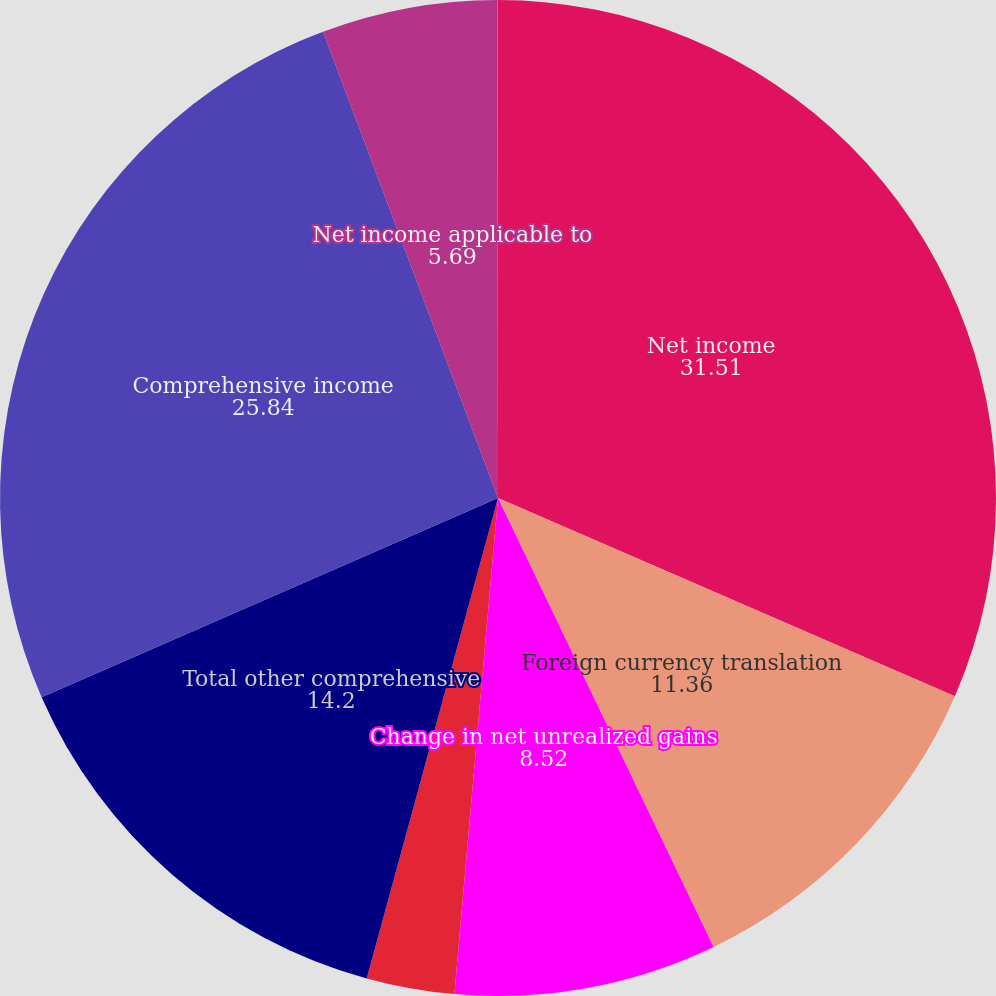<chart> <loc_0><loc_0><loc_500><loc_500><pie_chart><fcel>Net income<fcel>Foreign currency translation<fcel>Change in net unrealized gains<fcel>Pension postretirement and<fcel>Total other comprehensive<fcel>Comprehensive income<fcel>Net income applicable to<fcel>Other comprehensive income<nl><fcel>31.51%<fcel>11.36%<fcel>8.52%<fcel>2.85%<fcel>14.2%<fcel>25.84%<fcel>5.69%<fcel>0.02%<nl></chart> 